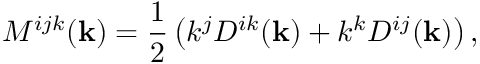<formula> <loc_0><loc_0><loc_500><loc_500>M ^ { i j k } ( { k } ) = \frac { 1 } { 2 } \left ( k ^ { j } D ^ { i k } ( { k } ) + k ^ { k } D ^ { i j } ( { k } ) \right ) ,</formula> 